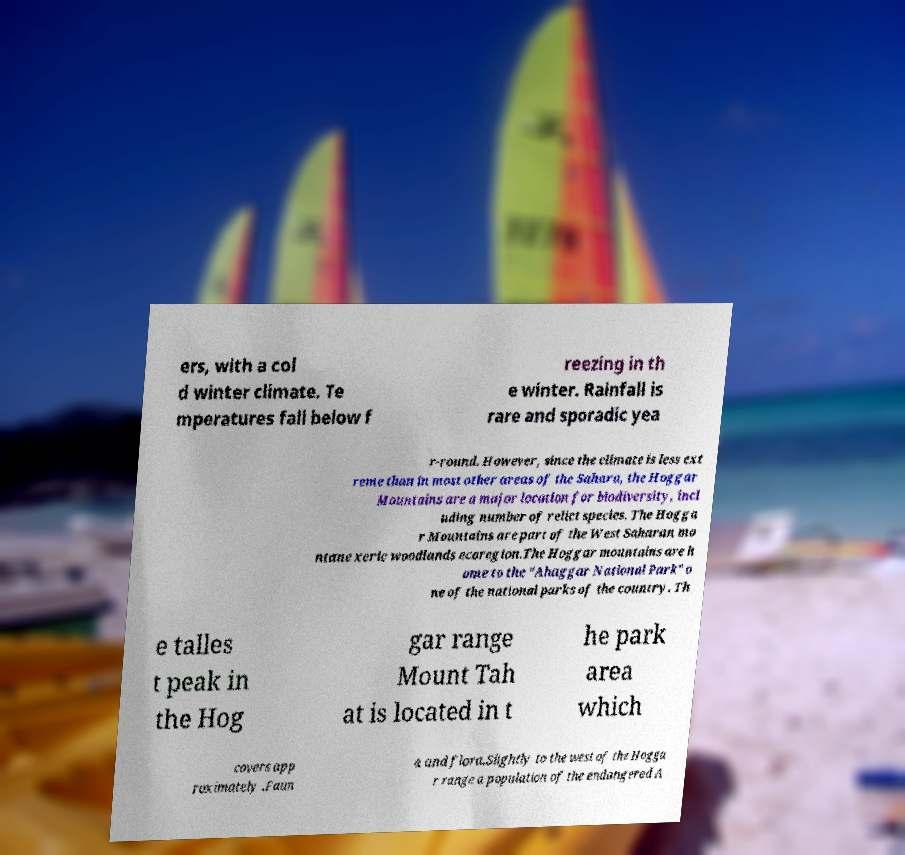I need the written content from this picture converted into text. Can you do that? ers, with a col d winter climate. Te mperatures fall below f reezing in th e winter. Rainfall is rare and sporadic yea r-round. However, since the climate is less ext reme than in most other areas of the Sahara, the Hoggar Mountains are a major location for biodiversity, incl uding number of relict species. The Hogga r Mountains are part of the West Saharan mo ntane xeric woodlands ecoregion.The Hoggar mountains are h ome to the "Ahaggar National Park" o ne of the national parks of the country. Th e talles t peak in the Hog gar range Mount Tah at is located in t he park area which covers app roximately .Faun a and flora.Slightly to the west of the Hogga r range a population of the endangered A 